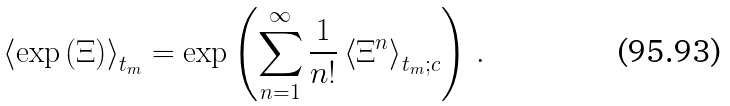<formula> <loc_0><loc_0><loc_500><loc_500>\left \langle \exp \left ( \Xi \right ) \right \rangle _ { t _ { m } } = \exp \left ( \sum _ { n = 1 } ^ { \infty } \frac { 1 } { n ! } \left \langle \Xi ^ { n } \right \rangle _ { t _ { m } ; c } \right ) \, .</formula> 